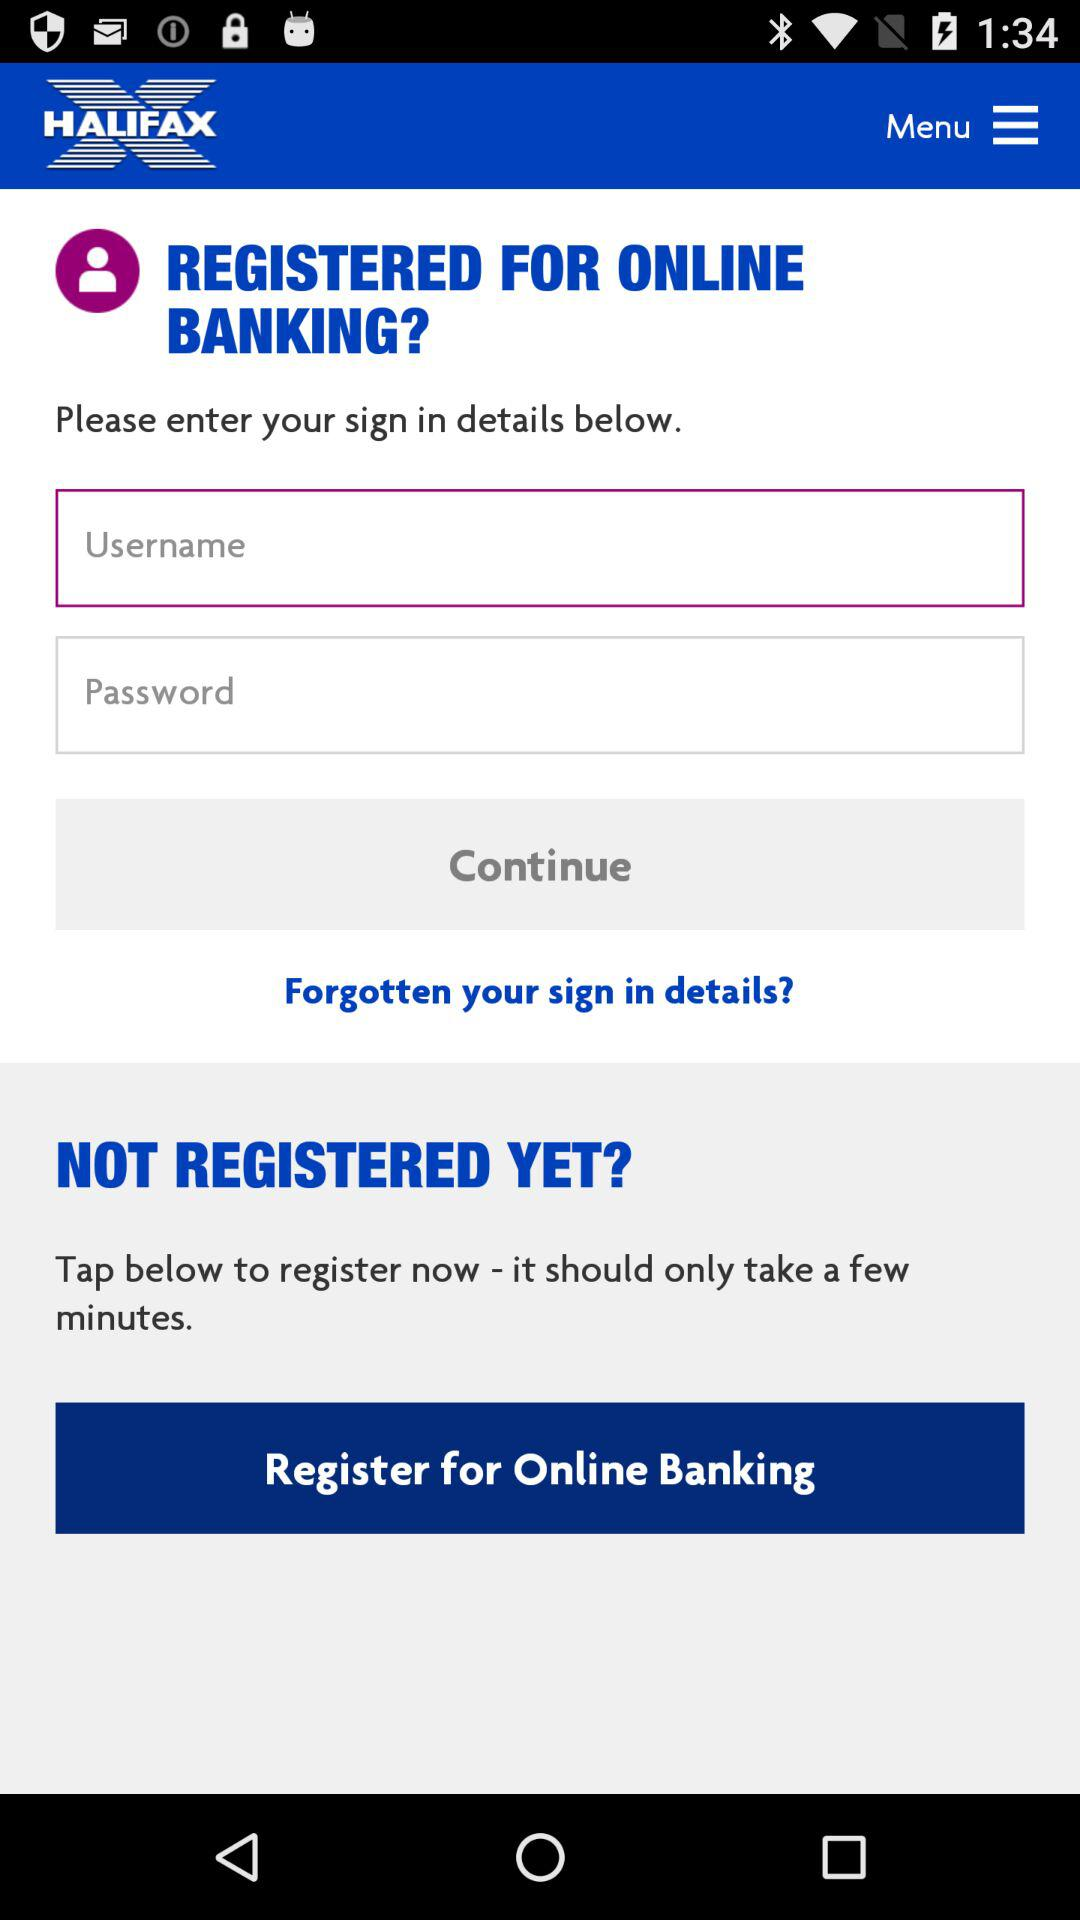How many characters are required to create a password?
When the provided information is insufficient, respond with <no answer>. <no answer> 